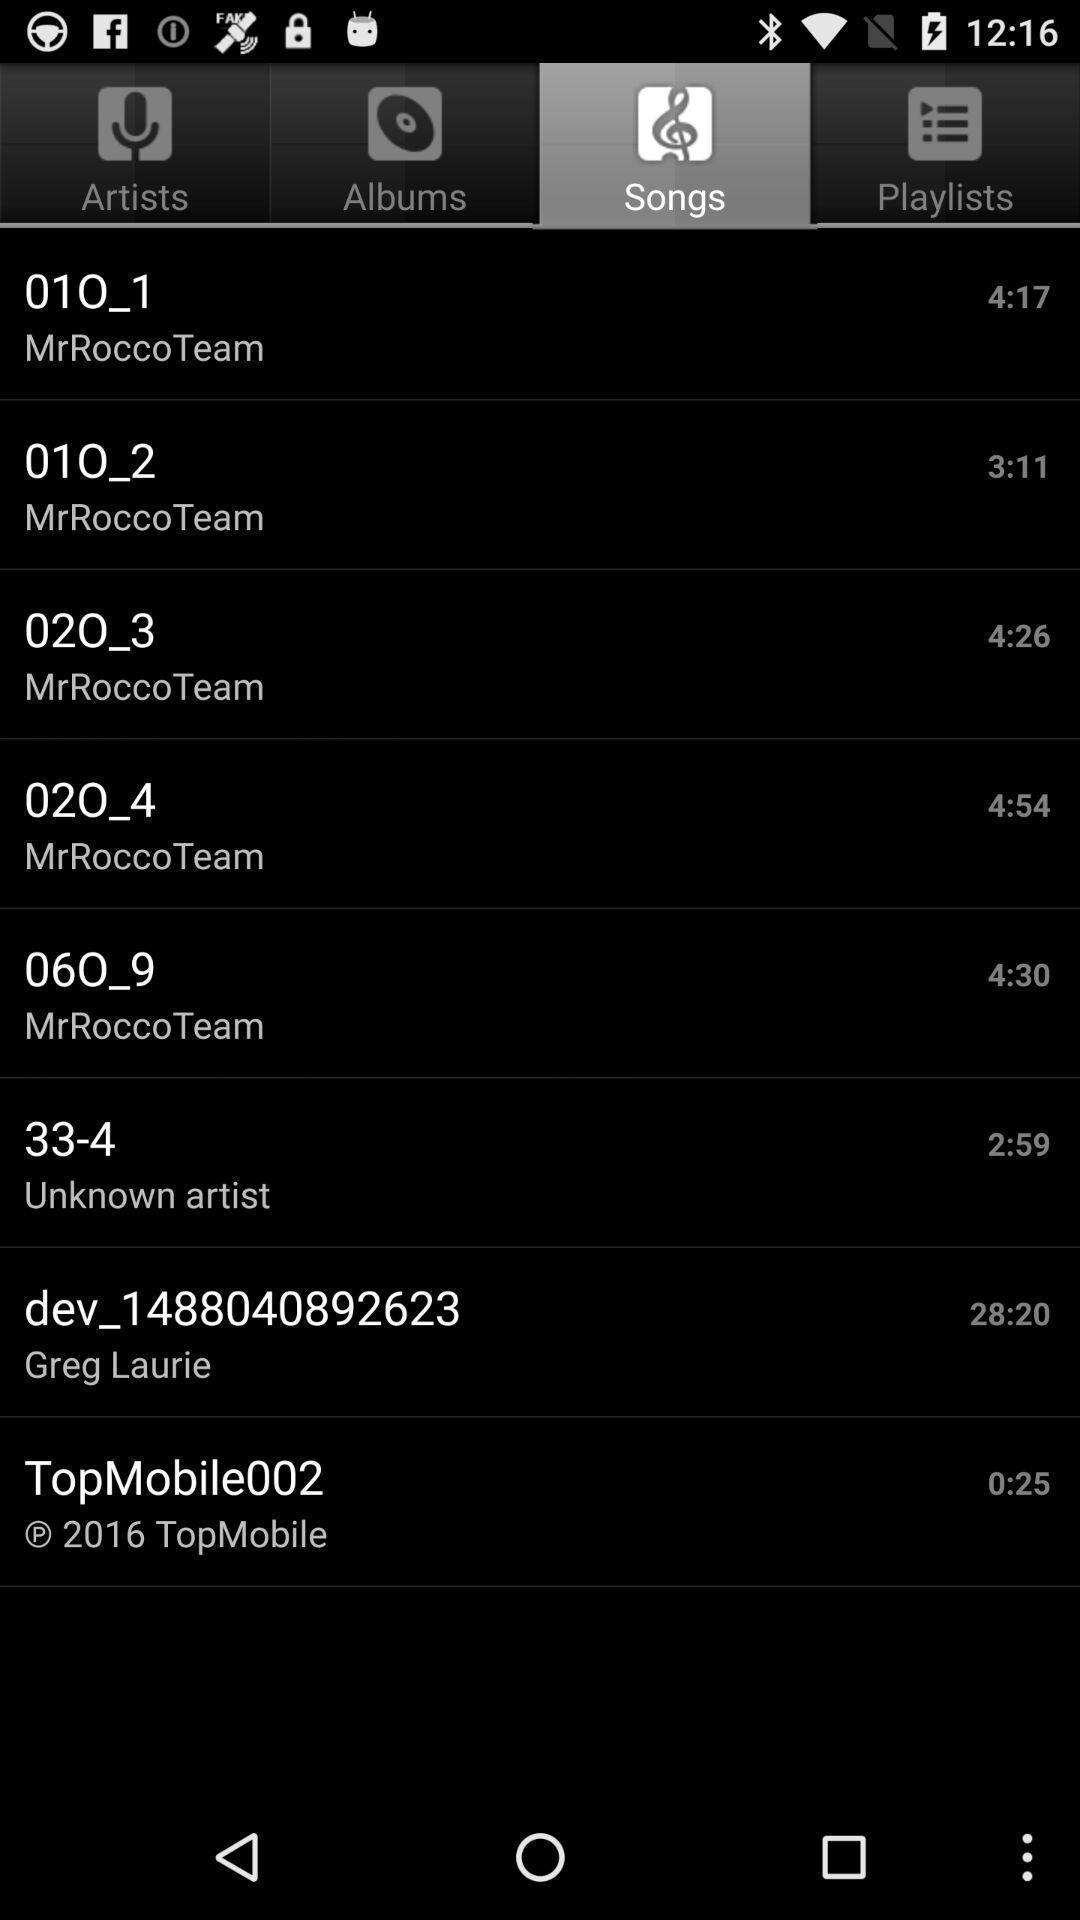Describe the key features of this screenshot. Page showing multiple audio clips. 